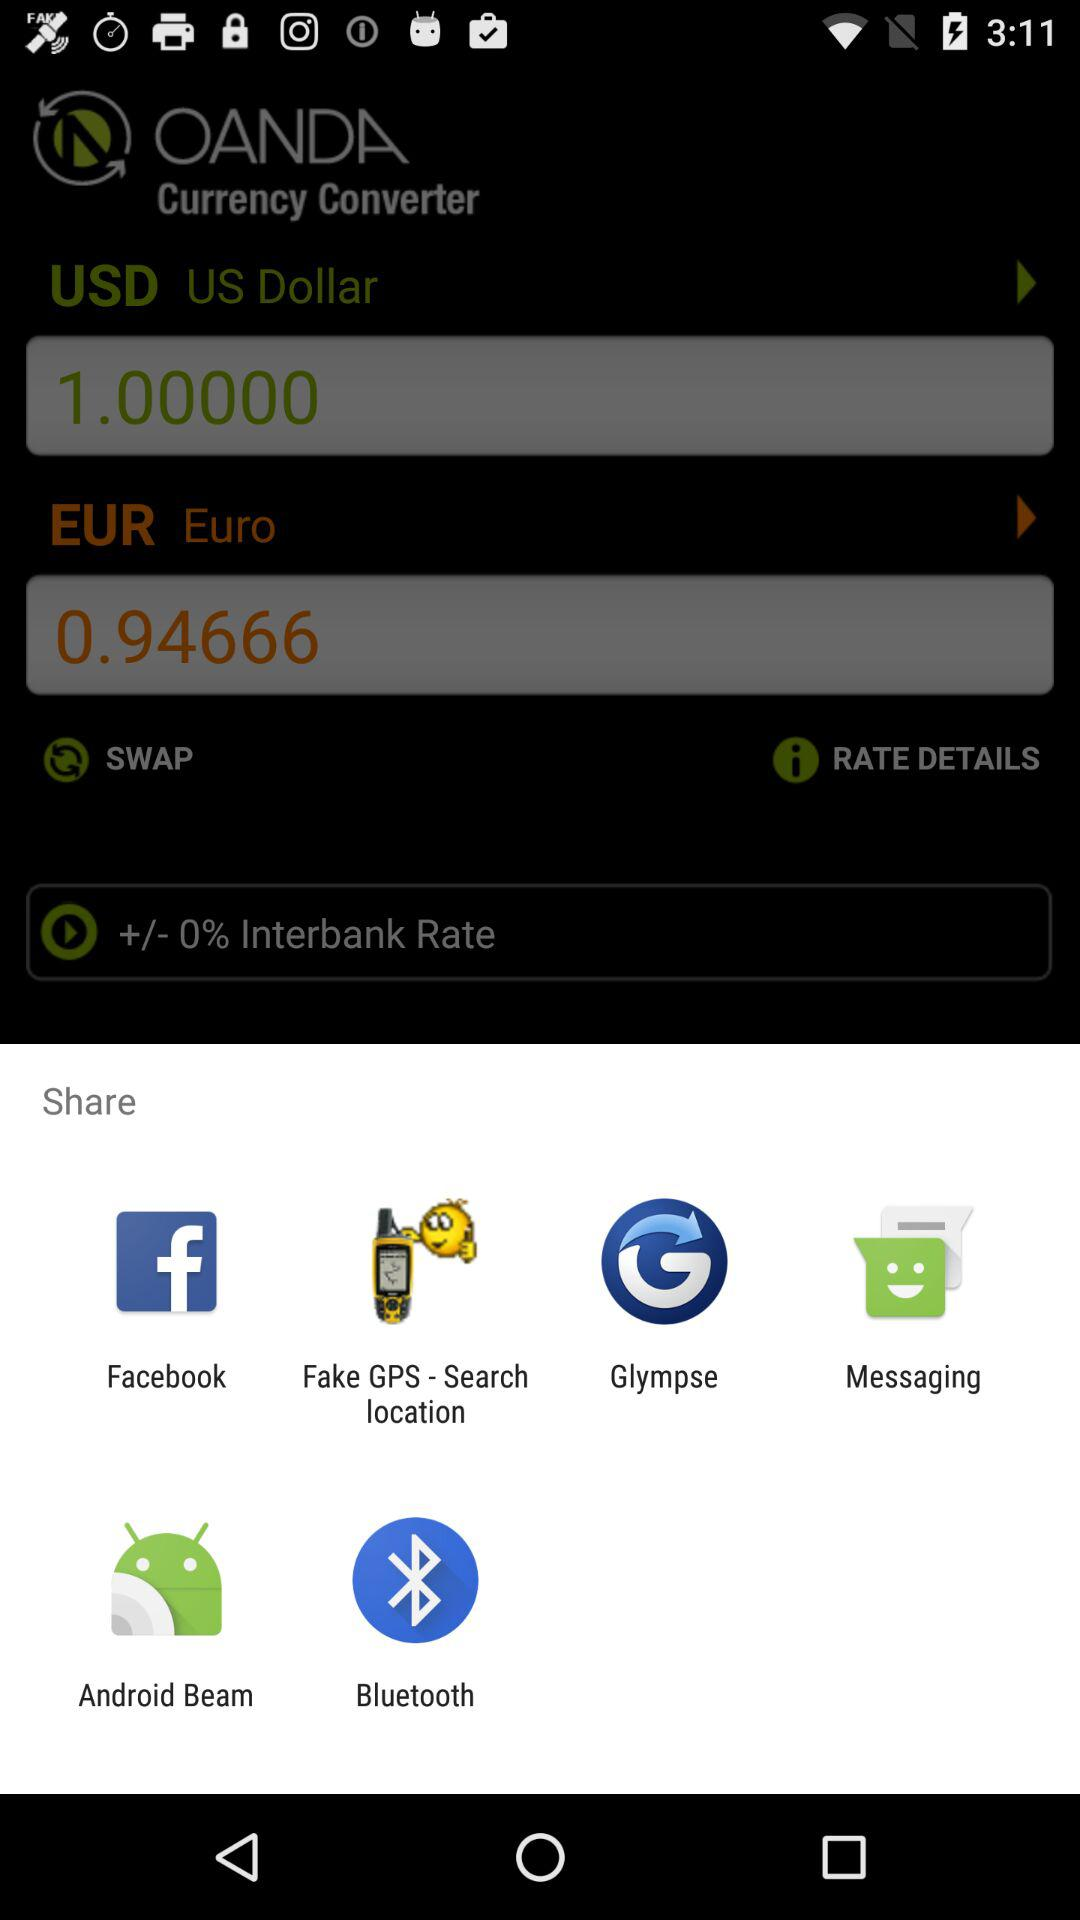What is the amount in euros? The amount in euros is 0.94666. 